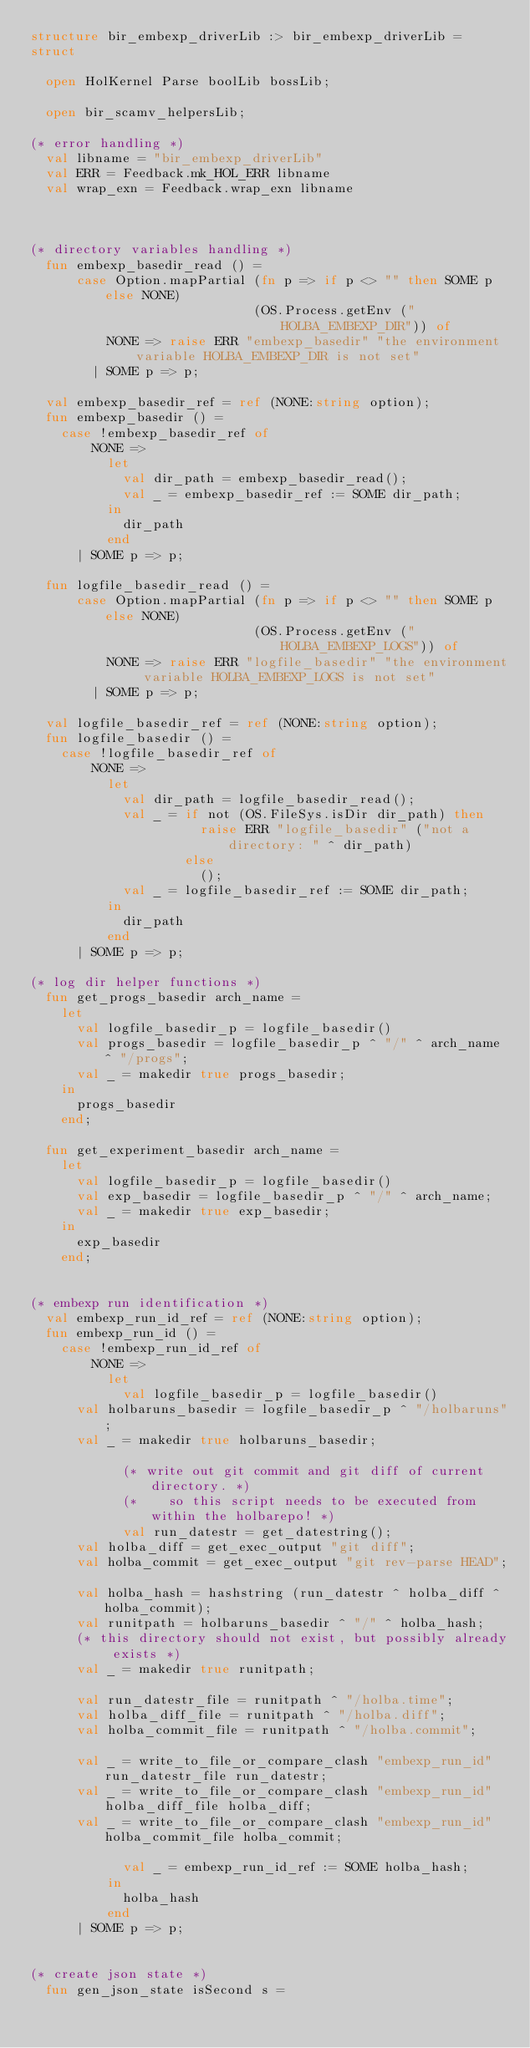<code> <loc_0><loc_0><loc_500><loc_500><_SML_>structure bir_embexp_driverLib :> bir_embexp_driverLib =
struct

  open HolKernel Parse boolLib bossLib;

  open bir_scamv_helpersLib;

(* error handling *)
  val libname = "bir_embexp_driverLib"
  val ERR = Feedback.mk_HOL_ERR libname
  val wrap_exn = Feedback.wrap_exn libname



(* directory variables handling *)
  fun embexp_basedir_read () =
      case Option.mapPartial (fn p => if p <> "" then SOME p else NONE)
                             (OS.Process.getEnv ("HOLBA_EMBEXP_DIR")) of
          NONE => raise ERR "embexp_basedir" "the environment variable HOLBA_EMBEXP_DIR is not set"
        | SOME p => p;

  val embexp_basedir_ref = ref (NONE:string option);
  fun embexp_basedir () =
    case !embexp_basedir_ref of
        NONE =>
          let
            val dir_path = embexp_basedir_read();
            val _ = embexp_basedir_ref := SOME dir_path;
          in
            dir_path
          end
      | SOME p => p;

  fun logfile_basedir_read () =
      case Option.mapPartial (fn p => if p <> "" then SOME p else NONE)
                             (OS.Process.getEnv ("HOLBA_EMBEXP_LOGS")) of
          NONE => raise ERR "logfile_basedir" "the environment variable HOLBA_EMBEXP_LOGS is not set"
        | SOME p => p;

  val logfile_basedir_ref = ref (NONE:string option);
  fun logfile_basedir () =
    case !logfile_basedir_ref of
        NONE =>
          let
            val dir_path = logfile_basedir_read();
            val _ = if not (OS.FileSys.isDir dir_path) then
                      raise ERR "logfile_basedir" ("not a directory: " ^ dir_path)
                    else
                      ();
            val _ = logfile_basedir_ref := SOME dir_path;
          in
            dir_path
          end
      | SOME p => p;

(* log dir helper functions *)
  fun get_progs_basedir arch_name =
    let
      val logfile_basedir_p = logfile_basedir()
      val progs_basedir = logfile_basedir_p ^ "/" ^ arch_name ^ "/progs";
      val _ = makedir true progs_basedir;
    in
      progs_basedir
    end;

  fun get_experiment_basedir arch_name =
    let
      val logfile_basedir_p = logfile_basedir()
      val exp_basedir = logfile_basedir_p ^ "/" ^ arch_name;
      val _ = makedir true exp_basedir;
    in
      exp_basedir
    end;


(* embexp run identification *)
  val embexp_run_id_ref = ref (NONE:string option);
  fun embexp_run_id () =
    case !embexp_run_id_ref of
        NONE =>
          let
            val logfile_basedir_p = logfile_basedir()
	    val holbaruns_basedir = logfile_basedir_p ^ "/holbaruns";
	    val _ = makedir true holbaruns_basedir;

            (* write out git commit and git diff of current directory. *)
            (*    so this script needs to be executed from within the holbarepo! *)
            val run_datestr = get_datestring();
	    val holba_diff = get_exec_output "git diff";
	    val holba_commit = get_exec_output "git rev-parse HEAD";

	    val holba_hash = hashstring (run_datestr ^ holba_diff ^ holba_commit);
	    val runitpath = holbaruns_basedir ^ "/" ^ holba_hash;
	    (* this directory should not exist, but possibly already exists *)
	    val _ = makedir true runitpath;

	    val run_datestr_file = runitpath ^ "/holba.time";
	    val holba_diff_file = runitpath ^ "/holba.diff";
	    val holba_commit_file = runitpath ^ "/holba.commit";

	    val _ = write_to_file_or_compare_clash "embexp_run_id" run_datestr_file run_datestr;
	    val _ = write_to_file_or_compare_clash "embexp_run_id" holba_diff_file holba_diff;
	    val _ = write_to_file_or_compare_clash "embexp_run_id" holba_commit_file holba_commit;

            val _ = embexp_run_id_ref := SOME holba_hash;
          in
            holba_hash
          end
      | SOME p => p;


(* create json state *)
  fun gen_json_state isSecond s =</code> 